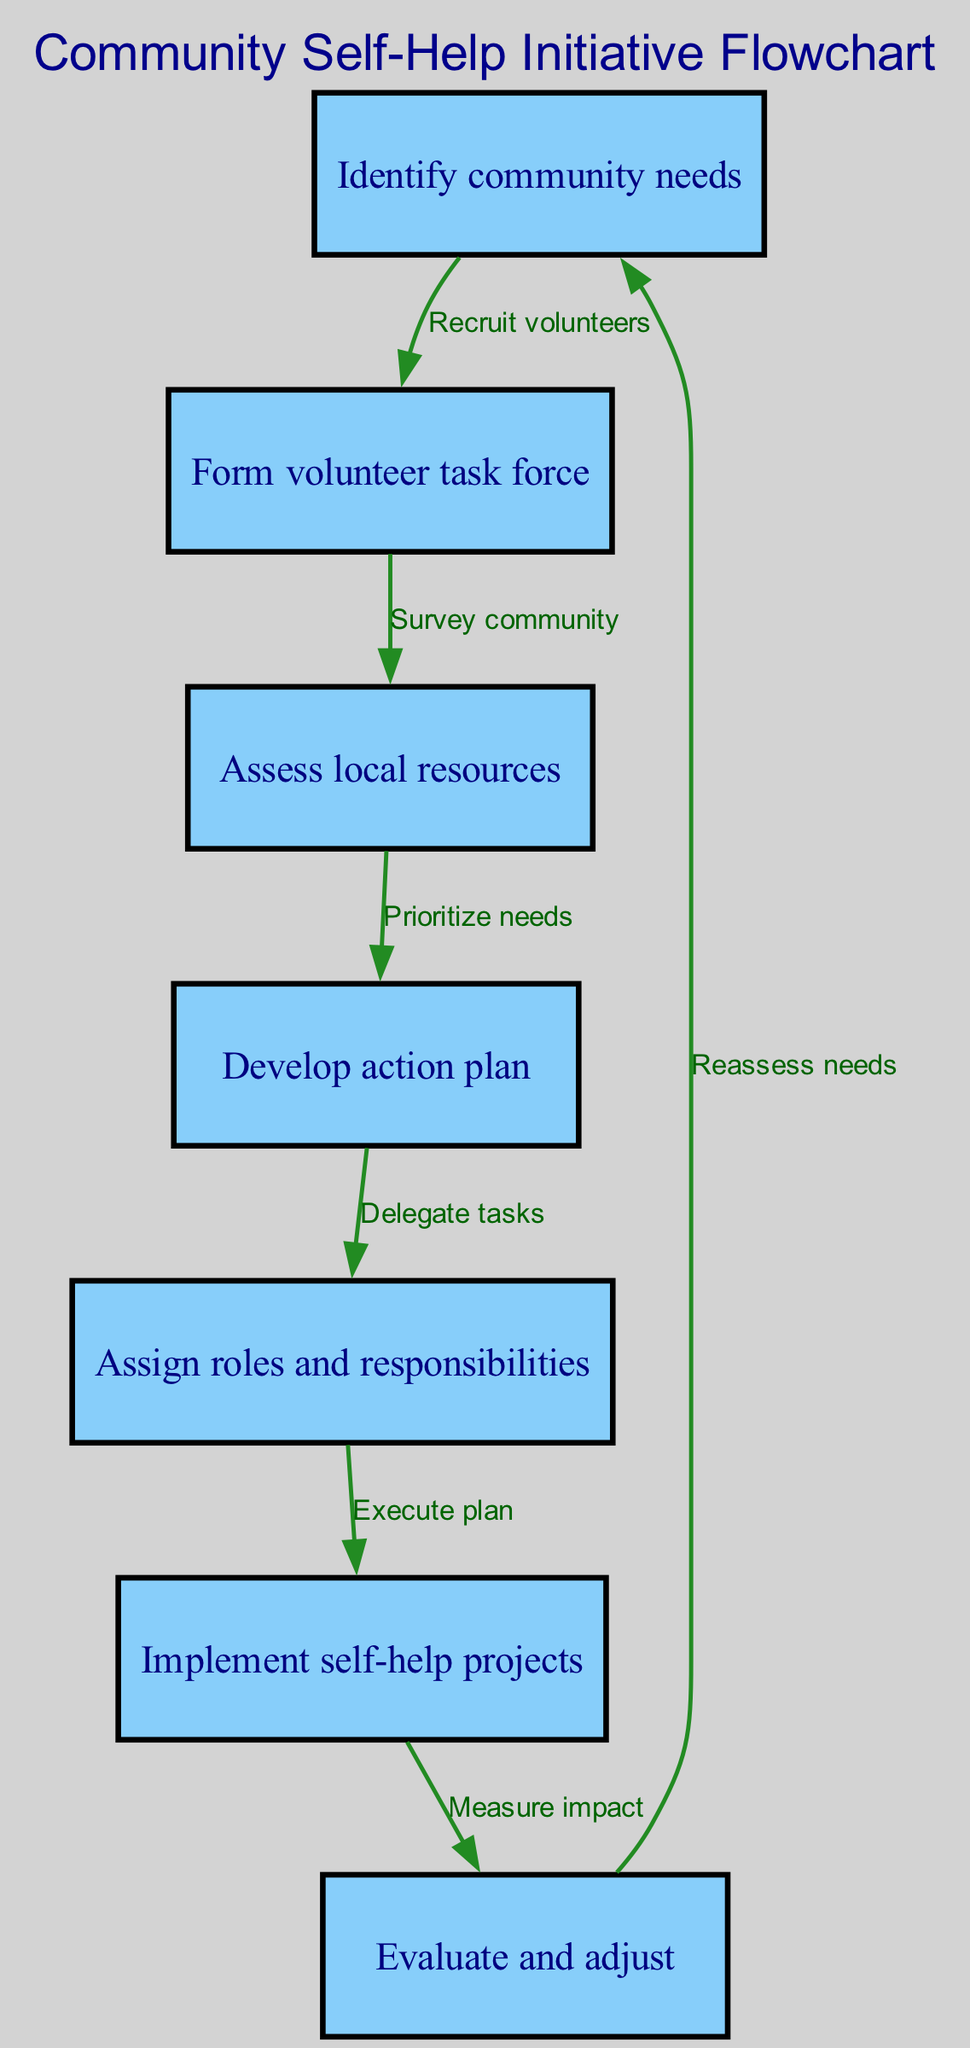What is the first step in the community self-help initiative? The first step listed in the diagram is "Identify community needs." This is indicated as the initial node in the flowchart.
Answer: Identify community needs How many nodes are in the flowchart? Counting all the nodes presented in the diagram, there are a total of seven nodes, each representing a distinct step in the initiative process.
Answer: 7 What does the edge from "Implement self-help projects" to "Evaluate and adjust" describe? This edge indicates the action of measuring the impact after the projects have been implemented, which leads to the evaluation and adjustment phase necessary for ongoing improvement.
Answer: Measure impact Which two steps are directly connected before developing the action plan? Before the "Develop action plan," there is a direct connection from "Assess local resources" to "Develop action plan," indicating that local resource assessment is necessary before planning actions.
Answer: Assess local resources, Develop action plan What is the relationship between "Evaluate and adjust" and "Identify community needs"? The relationship is cyclical; after evaluating and adjusting the projects, the process leads back to "Identify community needs," indicating a continuous cycle of assessment and improvement.
Answer: Reassess needs 